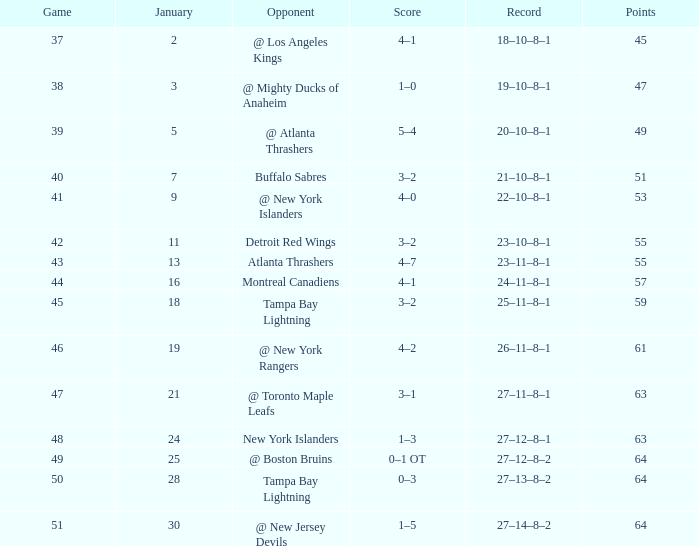How many points does january have with 18? 1.0. 